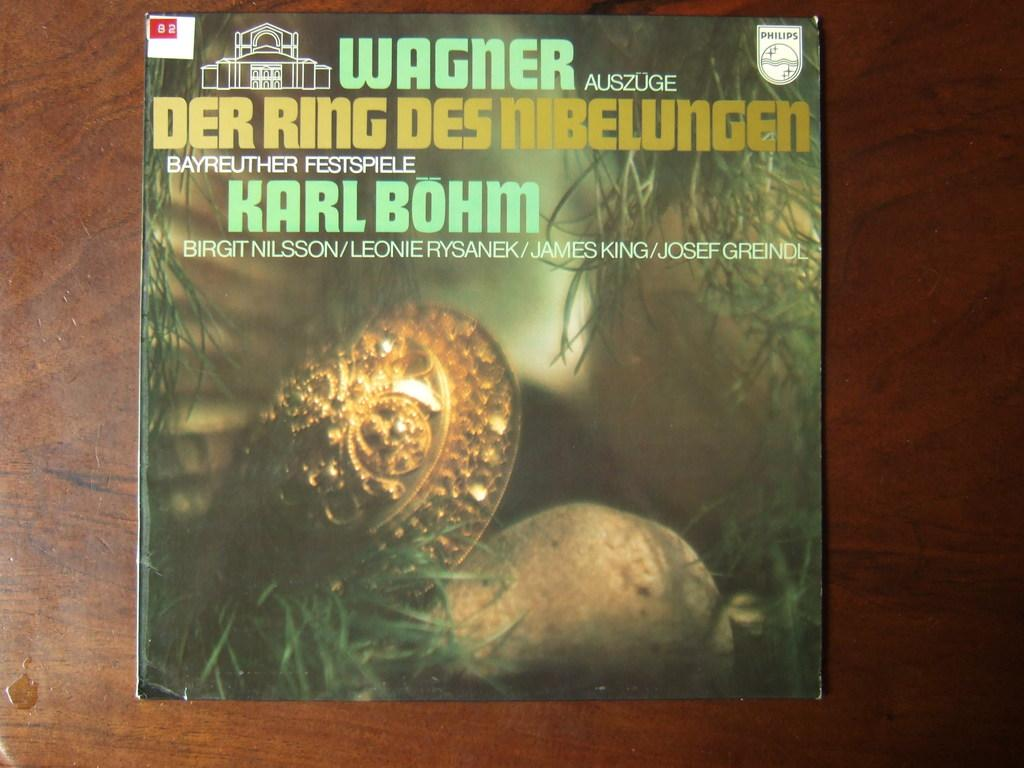<image>
Share a concise interpretation of the image provided. A vinyl record called Wagner Der Ring Des Nibelungen. 